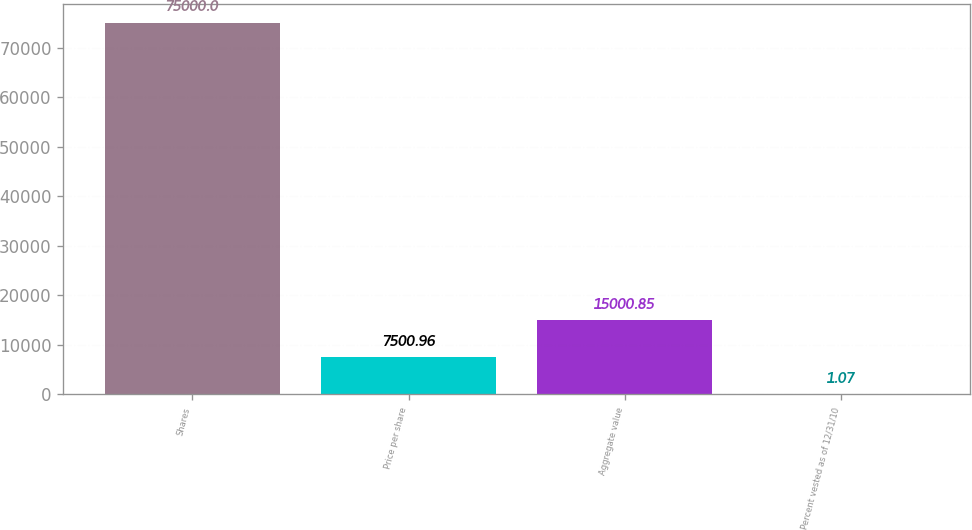<chart> <loc_0><loc_0><loc_500><loc_500><bar_chart><fcel>Shares<fcel>Price per share<fcel>Aggregate value<fcel>Percent vested as of 12/31/10<nl><fcel>75000<fcel>7500.96<fcel>15000.9<fcel>1.07<nl></chart> 